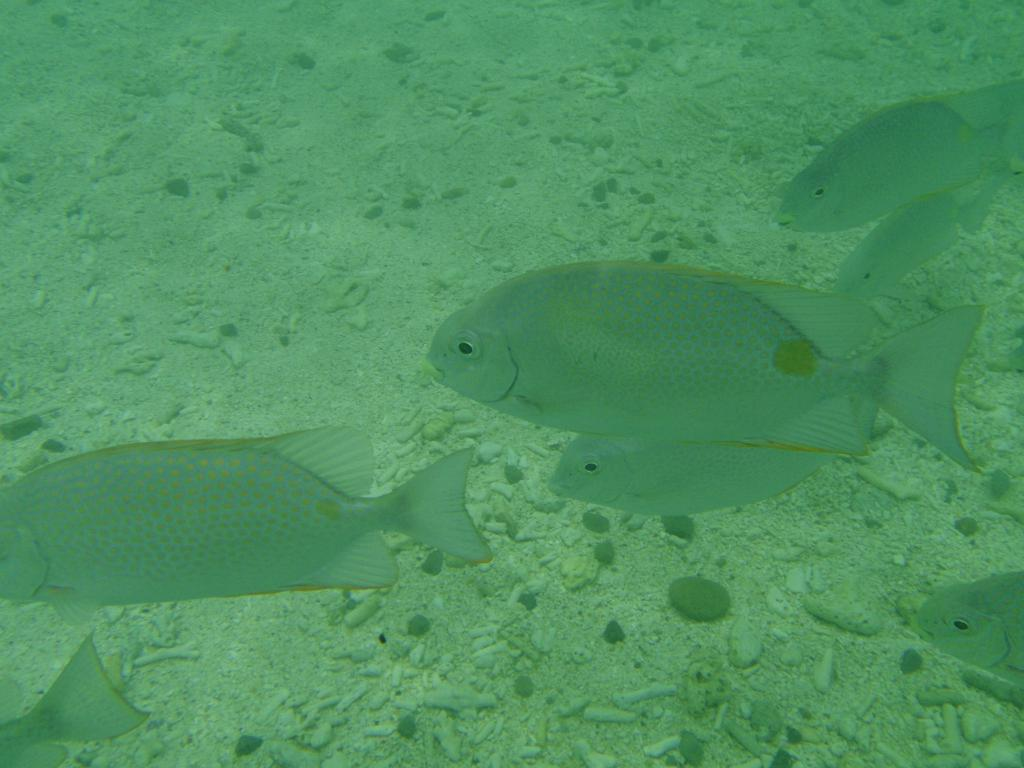What type of animals can be seen in the water in the image? There are fishes in the water in the image. What color are the fishes? The fishes are green in color. What can be seen below the water in the image? There is ground visible in the image. What is present on the ground in the image? There are small rocks on the ground. What type of bean is growing on the ground in the image? There are no beans present in the image; it features fishes in the water and small rocks on the ground. What toy can be seen floating in the water with the fishes? There are no toys present in the water with the fishes; only the green fishes can be seen. 